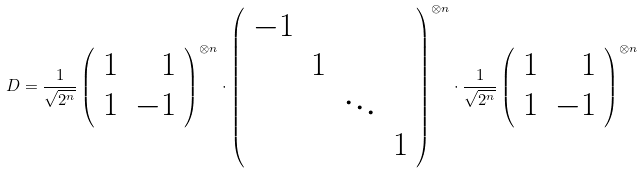<formula> <loc_0><loc_0><loc_500><loc_500>D = \frac { 1 } { \sqrt { 2 ^ { n } } } \left ( \begin{array} { r r } 1 & 1 \\ 1 & - 1 \end{array} \right ) ^ { \otimes n } \cdot \left ( \begin{array} { r r r r } - 1 & \\ & 1 \\ & & \ddots \\ & & & 1 \end{array} \right ) ^ { \otimes n } \cdot \frac { 1 } { \sqrt { 2 ^ { n } } } \left ( \begin{array} { r r } 1 & 1 \\ 1 & - 1 \end{array} \right ) ^ { \otimes n }</formula> 